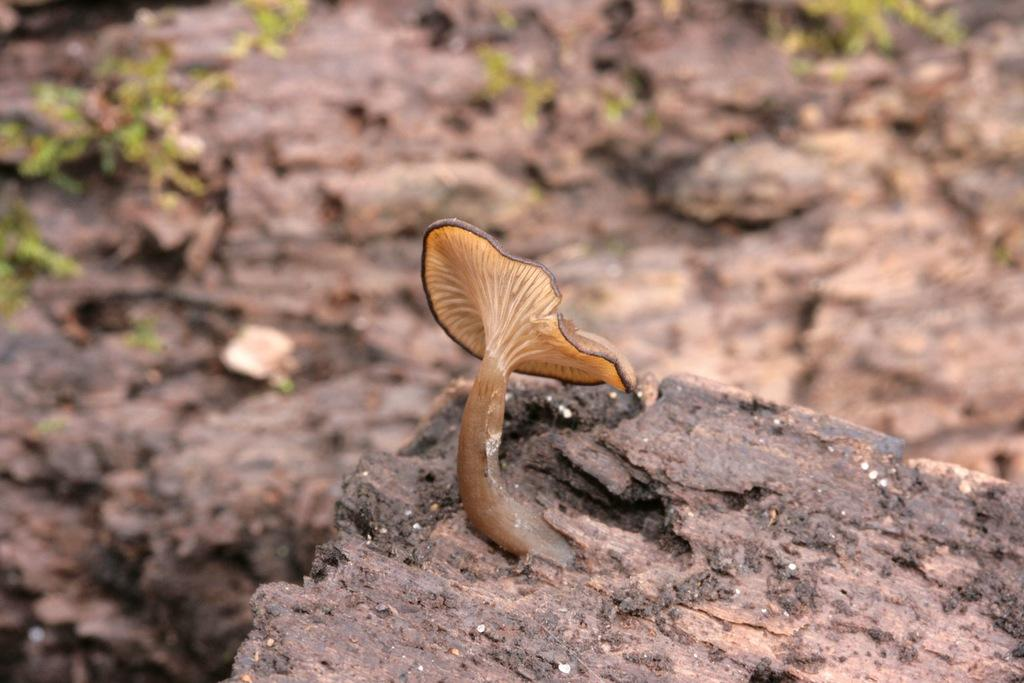What type of fungus can be seen in the image? There is a mushroom in the image. What type of vegetation is present on the ground in the image? There are green leaves on the ground in the image. What type of pancake is being served at the event in the image? There is no event or pancake present in the image; it only features a mushroom and green leaves on the ground. 